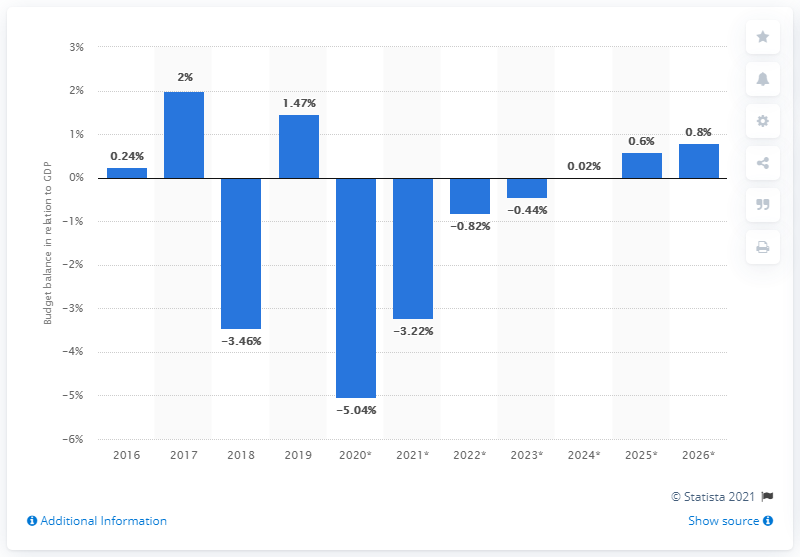Mention a couple of crucial points in this snapshot. In 2019, Cyprus's budget surplus was 1.47% of its GDP. 